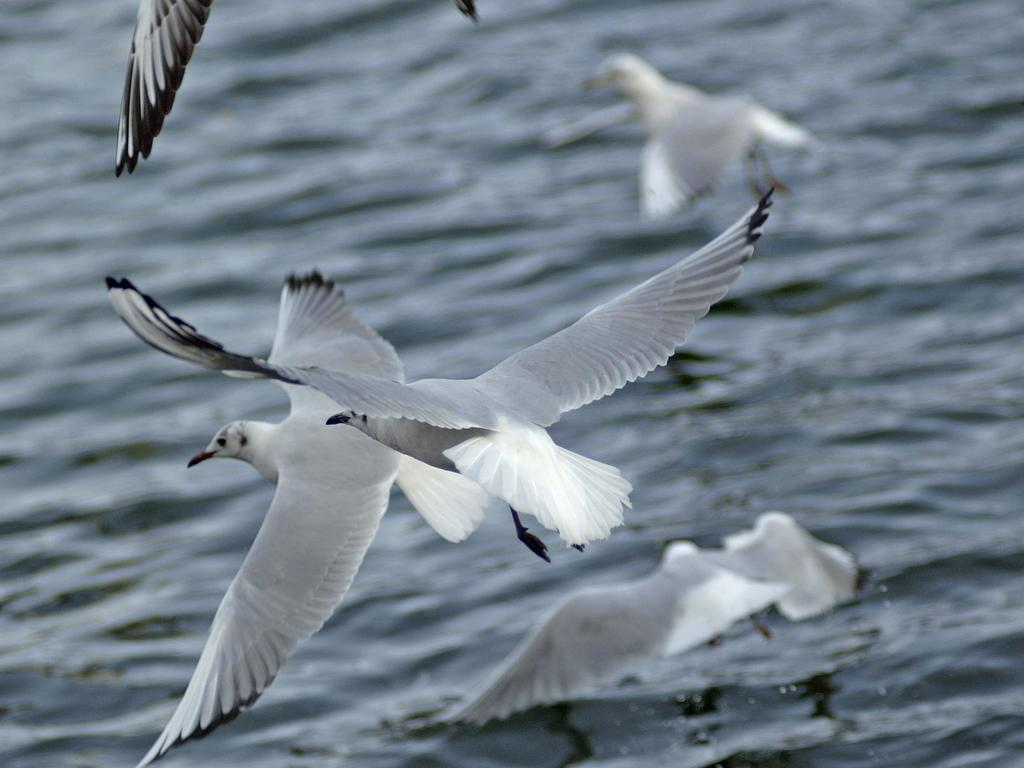What type of animals can be seen in the image? There are birds in the image. Where are the birds located in relation to the water? The birds are above the water. Can you describe the background of the image? The background of the image is blurred. What type of pin can be seen holding the ticket in the image? There is no pin or ticket present in the image; it features birds above the water with a blurred background. 